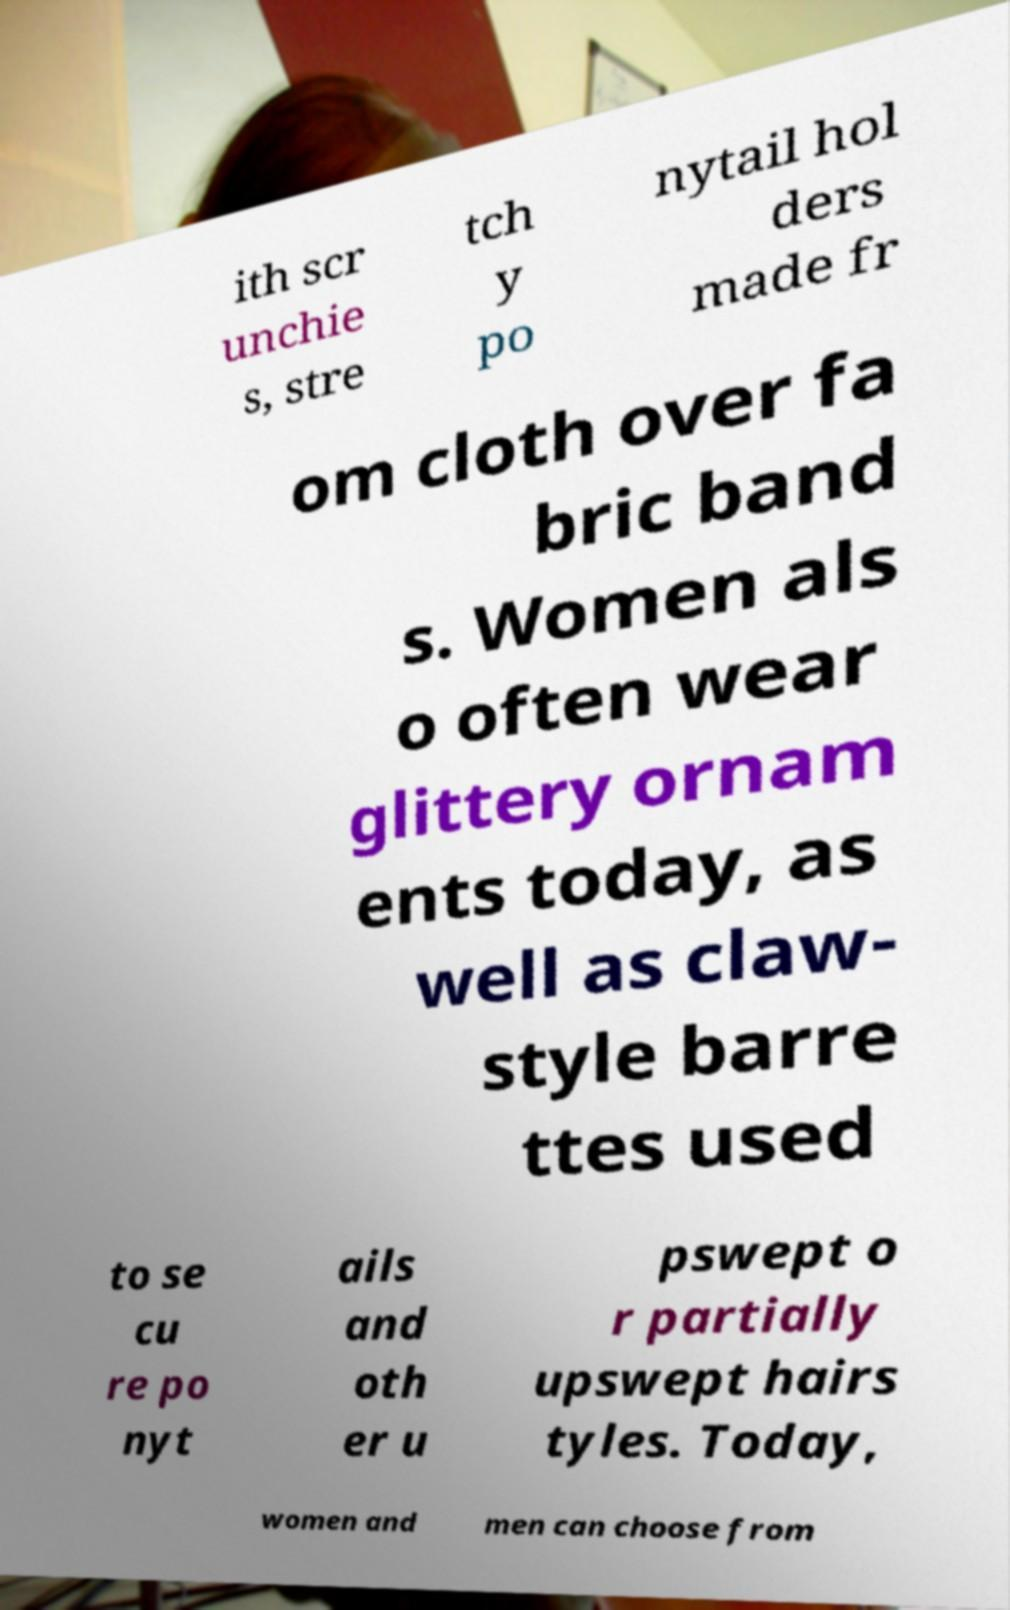Please identify and transcribe the text found in this image. ith scr unchie s, stre tch y po nytail hol ders made fr om cloth over fa bric band s. Women als o often wear glittery ornam ents today, as well as claw- style barre ttes used to se cu re po nyt ails and oth er u pswept o r partially upswept hairs tyles. Today, women and men can choose from 